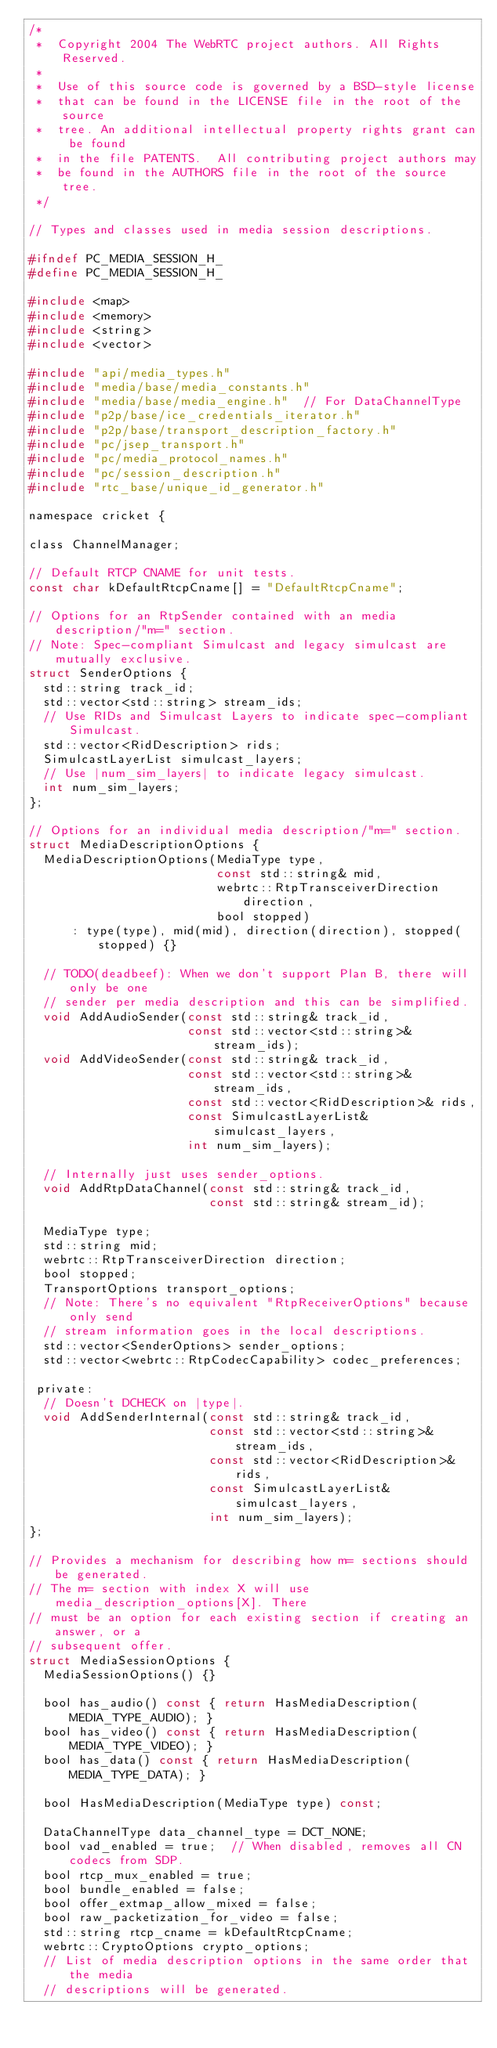<code> <loc_0><loc_0><loc_500><loc_500><_C_>/*
 *  Copyright 2004 The WebRTC project authors. All Rights Reserved.
 *
 *  Use of this source code is governed by a BSD-style license
 *  that can be found in the LICENSE file in the root of the source
 *  tree. An additional intellectual property rights grant can be found
 *  in the file PATENTS.  All contributing project authors may
 *  be found in the AUTHORS file in the root of the source tree.
 */

// Types and classes used in media session descriptions.

#ifndef PC_MEDIA_SESSION_H_
#define PC_MEDIA_SESSION_H_

#include <map>
#include <memory>
#include <string>
#include <vector>

#include "api/media_types.h"
#include "media/base/media_constants.h"
#include "media/base/media_engine.h"  // For DataChannelType
#include "p2p/base/ice_credentials_iterator.h"
#include "p2p/base/transport_description_factory.h"
#include "pc/jsep_transport.h"
#include "pc/media_protocol_names.h"
#include "pc/session_description.h"
#include "rtc_base/unique_id_generator.h"

namespace cricket {

class ChannelManager;

// Default RTCP CNAME for unit tests.
const char kDefaultRtcpCname[] = "DefaultRtcpCname";

// Options for an RtpSender contained with an media description/"m=" section.
// Note: Spec-compliant Simulcast and legacy simulcast are mutually exclusive.
struct SenderOptions {
  std::string track_id;
  std::vector<std::string> stream_ids;
  // Use RIDs and Simulcast Layers to indicate spec-compliant Simulcast.
  std::vector<RidDescription> rids;
  SimulcastLayerList simulcast_layers;
  // Use |num_sim_layers| to indicate legacy simulcast.
  int num_sim_layers;
};

// Options for an individual media description/"m=" section.
struct MediaDescriptionOptions {
  MediaDescriptionOptions(MediaType type,
                          const std::string& mid,
                          webrtc::RtpTransceiverDirection direction,
                          bool stopped)
      : type(type), mid(mid), direction(direction), stopped(stopped) {}

  // TODO(deadbeef): When we don't support Plan B, there will only be one
  // sender per media description and this can be simplified.
  void AddAudioSender(const std::string& track_id,
                      const std::vector<std::string>& stream_ids);
  void AddVideoSender(const std::string& track_id,
                      const std::vector<std::string>& stream_ids,
                      const std::vector<RidDescription>& rids,
                      const SimulcastLayerList& simulcast_layers,
                      int num_sim_layers);

  // Internally just uses sender_options.
  void AddRtpDataChannel(const std::string& track_id,
                         const std::string& stream_id);

  MediaType type;
  std::string mid;
  webrtc::RtpTransceiverDirection direction;
  bool stopped;
  TransportOptions transport_options;
  // Note: There's no equivalent "RtpReceiverOptions" because only send
  // stream information goes in the local descriptions.
  std::vector<SenderOptions> sender_options;
  std::vector<webrtc::RtpCodecCapability> codec_preferences;

 private:
  // Doesn't DCHECK on |type|.
  void AddSenderInternal(const std::string& track_id,
                         const std::vector<std::string>& stream_ids,
                         const std::vector<RidDescription>& rids,
                         const SimulcastLayerList& simulcast_layers,
                         int num_sim_layers);
};

// Provides a mechanism for describing how m= sections should be generated.
// The m= section with index X will use media_description_options[X]. There
// must be an option for each existing section if creating an answer, or a
// subsequent offer.
struct MediaSessionOptions {
  MediaSessionOptions() {}

  bool has_audio() const { return HasMediaDescription(MEDIA_TYPE_AUDIO); }
  bool has_video() const { return HasMediaDescription(MEDIA_TYPE_VIDEO); }
  bool has_data() const { return HasMediaDescription(MEDIA_TYPE_DATA); }

  bool HasMediaDescription(MediaType type) const;

  DataChannelType data_channel_type = DCT_NONE;
  bool vad_enabled = true;  // When disabled, removes all CN codecs from SDP.
  bool rtcp_mux_enabled = true;
  bool bundle_enabled = false;
  bool offer_extmap_allow_mixed = false;
  bool raw_packetization_for_video = false;
  std::string rtcp_cname = kDefaultRtcpCname;
  webrtc::CryptoOptions crypto_options;
  // List of media description options in the same order that the media
  // descriptions will be generated.</code> 